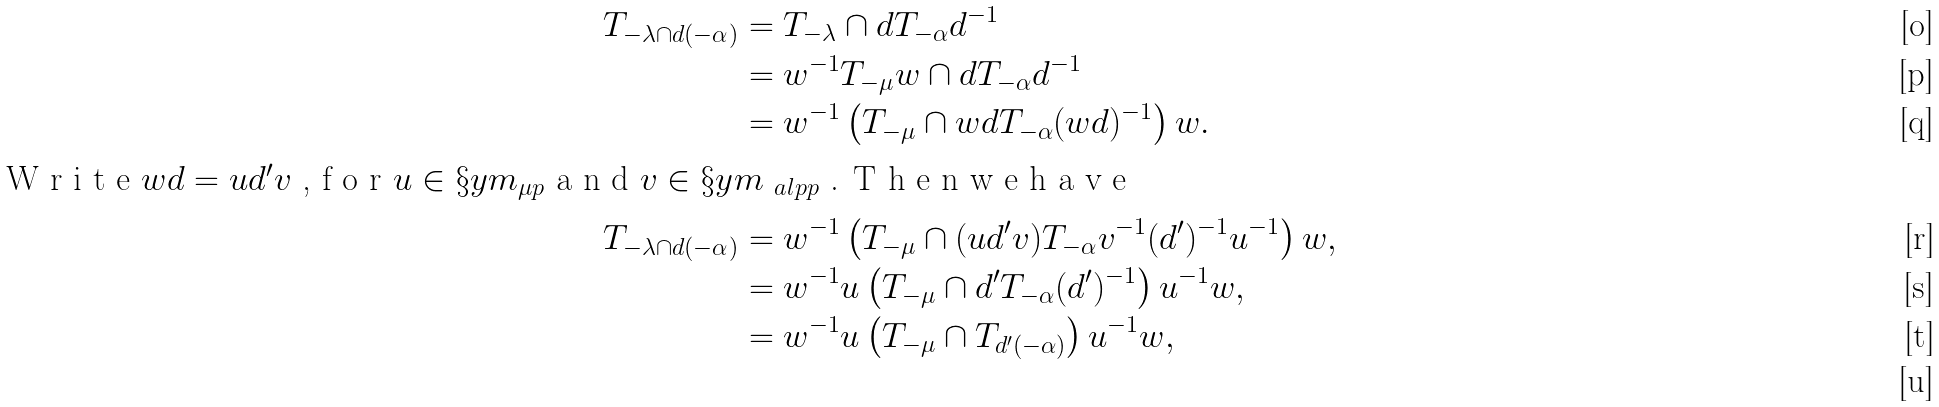Convert formula to latex. <formula><loc_0><loc_0><loc_500><loc_500>T _ { - \lambda \cap d ( - \alpha ) } & = T _ { - \lambda } \cap d T _ { - \alpha } d ^ { - 1 } \\ & = w ^ { - 1 } T _ { - \mu } w \cap d T _ { - \alpha } d ^ { - 1 } \\ & = w ^ { - 1 } \left ( T _ { - \mu } \cap w d T _ { - \alpha } ( w d ) ^ { - 1 } \right ) w . \\ \intertext { W r i t e $ w d = u d ^ { \prime } v $ , f o r $ u \in \S y m _ { \mu p } $ a n d $ v \in \S y m _ { \ a l p p } $ . T h e n w e h a v e } T _ { - \lambda \cap d ( - \alpha ) } & = w ^ { - 1 } \left ( T _ { - \mu } \cap ( u d ^ { \prime } v ) T _ { - \alpha } v ^ { - 1 } ( d ^ { \prime } ) ^ { - 1 } u ^ { - 1 } \right ) w , \\ & = w ^ { - 1 } u \left ( T _ { - \mu } \cap d ^ { \prime } T _ { - \alpha } ( d ^ { \prime } ) ^ { - 1 } \right ) u ^ { - 1 } w , \\ & = w ^ { - 1 } u \left ( T _ { - \mu } \cap T _ { d ^ { \prime } ( - \alpha ) } \right ) u ^ { - 1 } w , \\</formula> 